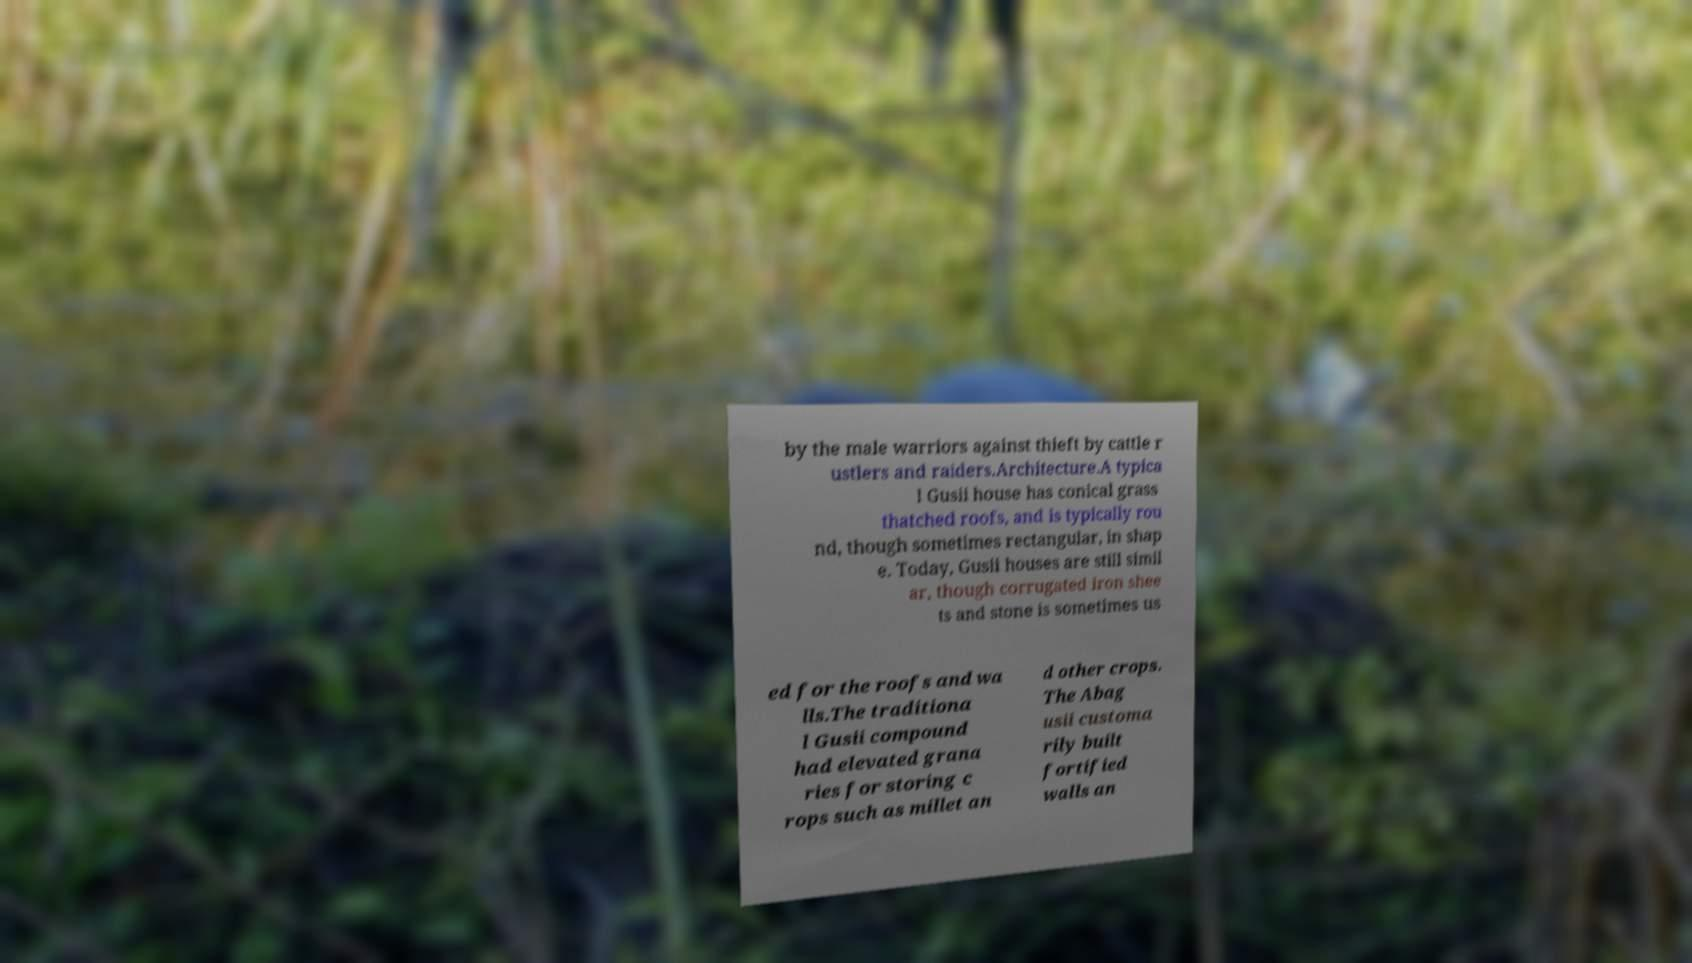For documentation purposes, I need the text within this image transcribed. Could you provide that? by the male warriors against thieft by cattle r ustlers and raiders.Architecture.A typica l Gusii house has conical grass thatched roofs, and is typically rou nd, though sometimes rectangular, in shap e. Today, Gusii houses are still simil ar, though corrugated iron shee ts and stone is sometimes us ed for the roofs and wa lls.The traditiona l Gusii compound had elevated grana ries for storing c rops such as millet an d other crops. The Abag usii customa rily built fortified walls an 